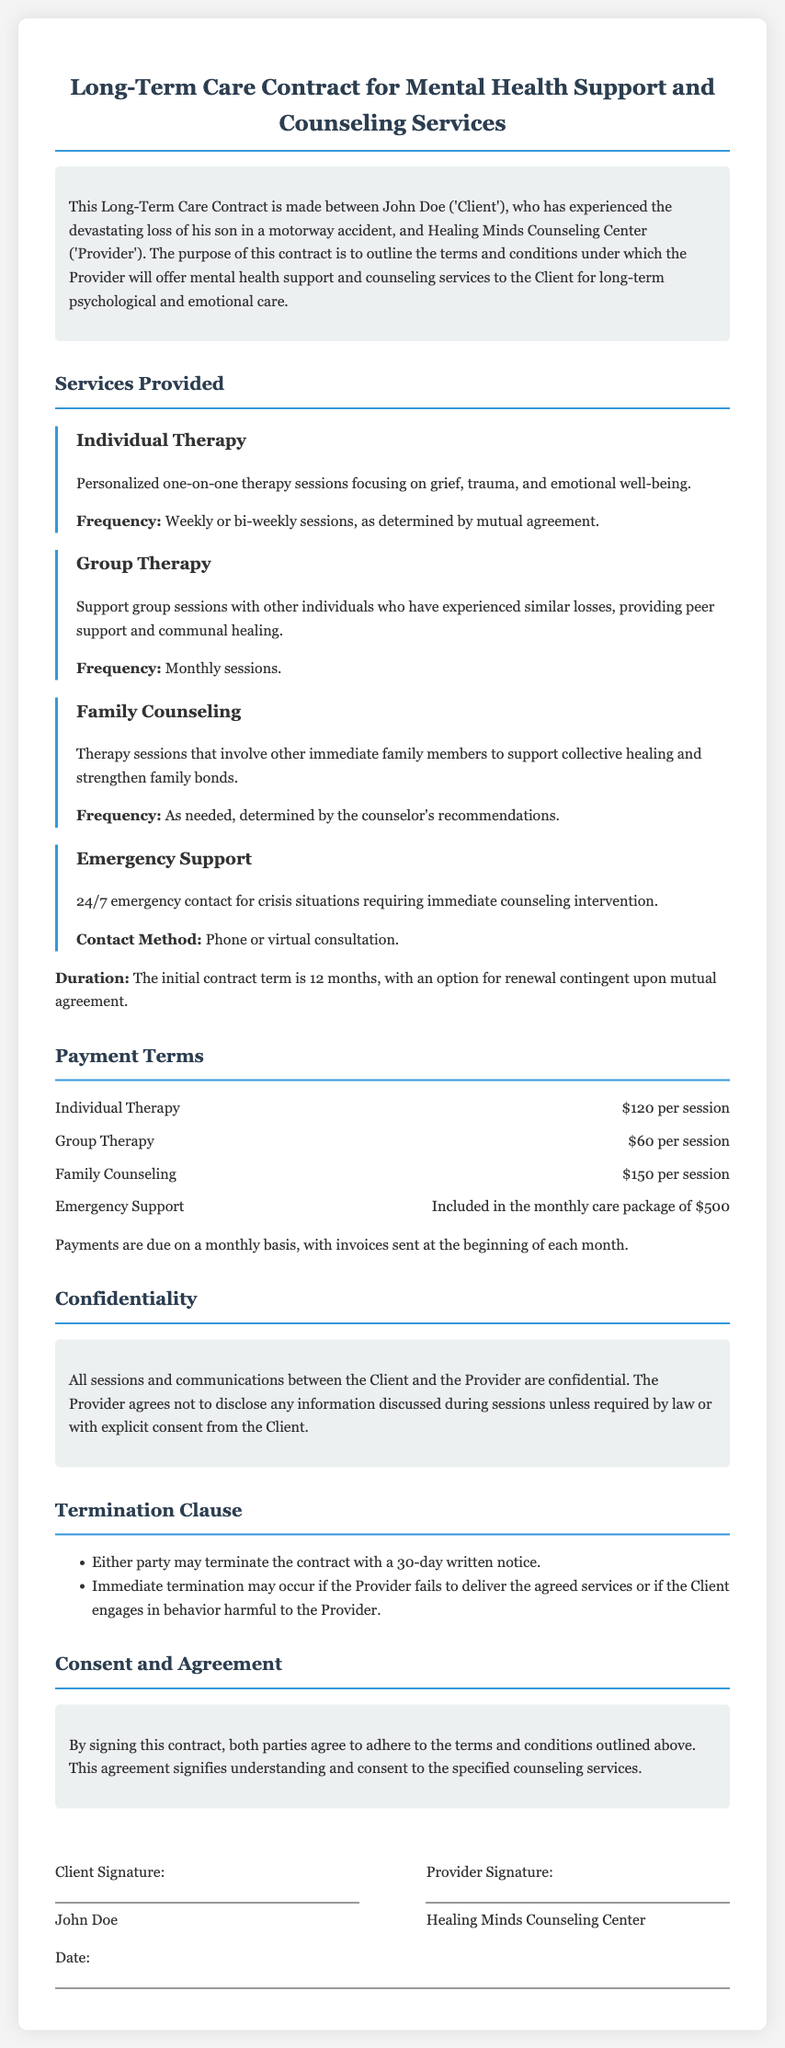What is the duration of the initial contract term? The initial contract term is specified to be 12 months.
Answer: 12 months What type of therapy involves other immediate family members? The document mentions Family Counseling as the type of therapy that includes other family members.
Answer: Family Counseling How much does individual therapy cost per session? The document states that individual therapy costs $120 per session.
Answer: $120 per session What is included in the monthly care package? The monthly care package includes Emergency Support as indicated in the payment terms.
Answer: Emergency Support How can the contract be terminated? The document outlines that either party can terminate the contract with a 30-day written notice.
Answer: 30-day written notice What is the frequency of group therapy sessions? The frequency of group therapy sessions is mentioned as monthly sessions.
Answer: Monthly sessions Who are the parties involved in this contract? The two parties involved in the contract are John Doe as the Client and Healing Minds Counseling Center as the Provider.
Answer: John Doe and Healing Minds Counseling Center What is the payment due date for invoices? Invoices are stated to be sent at the beginning of each month, indicating when payments are due.
Answer: Beginning of each month What must the Provider do to maintain confidentiality? The Provider agrees not to disclose any information discussed during sessions unless required by law or with explicit consent from the Client.
Answer: Not disclose any information 